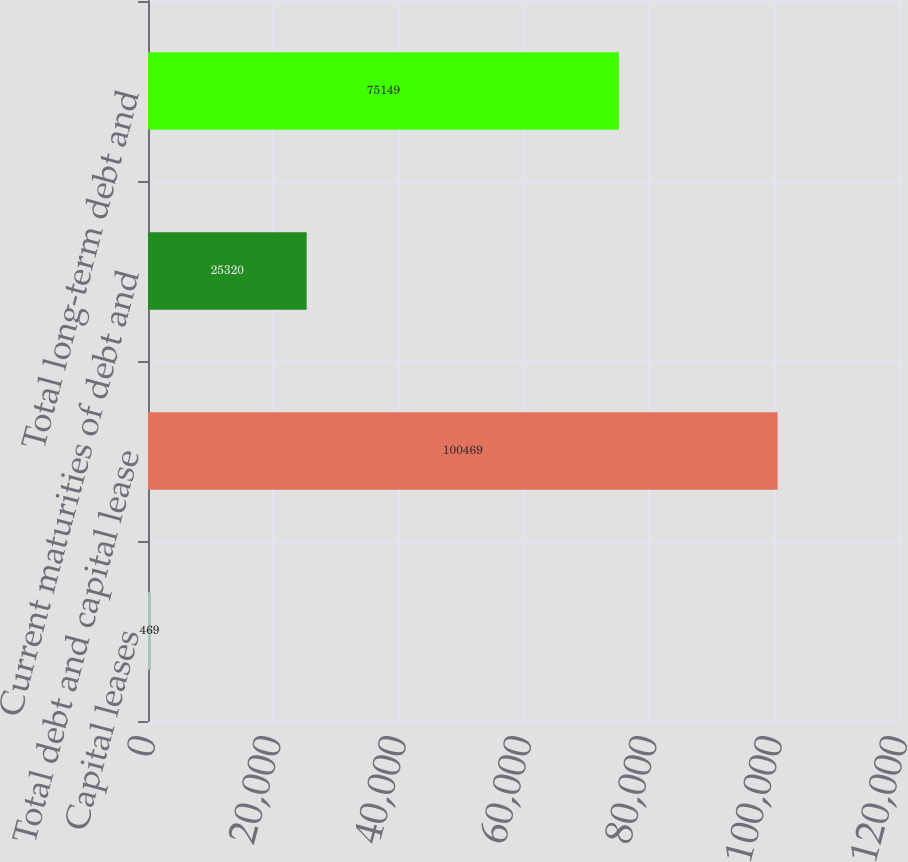<chart> <loc_0><loc_0><loc_500><loc_500><bar_chart><fcel>Capital leases<fcel>Total debt and capital lease<fcel>Current maturities of debt and<fcel>Total long-term debt and<nl><fcel>469<fcel>100469<fcel>25320<fcel>75149<nl></chart> 